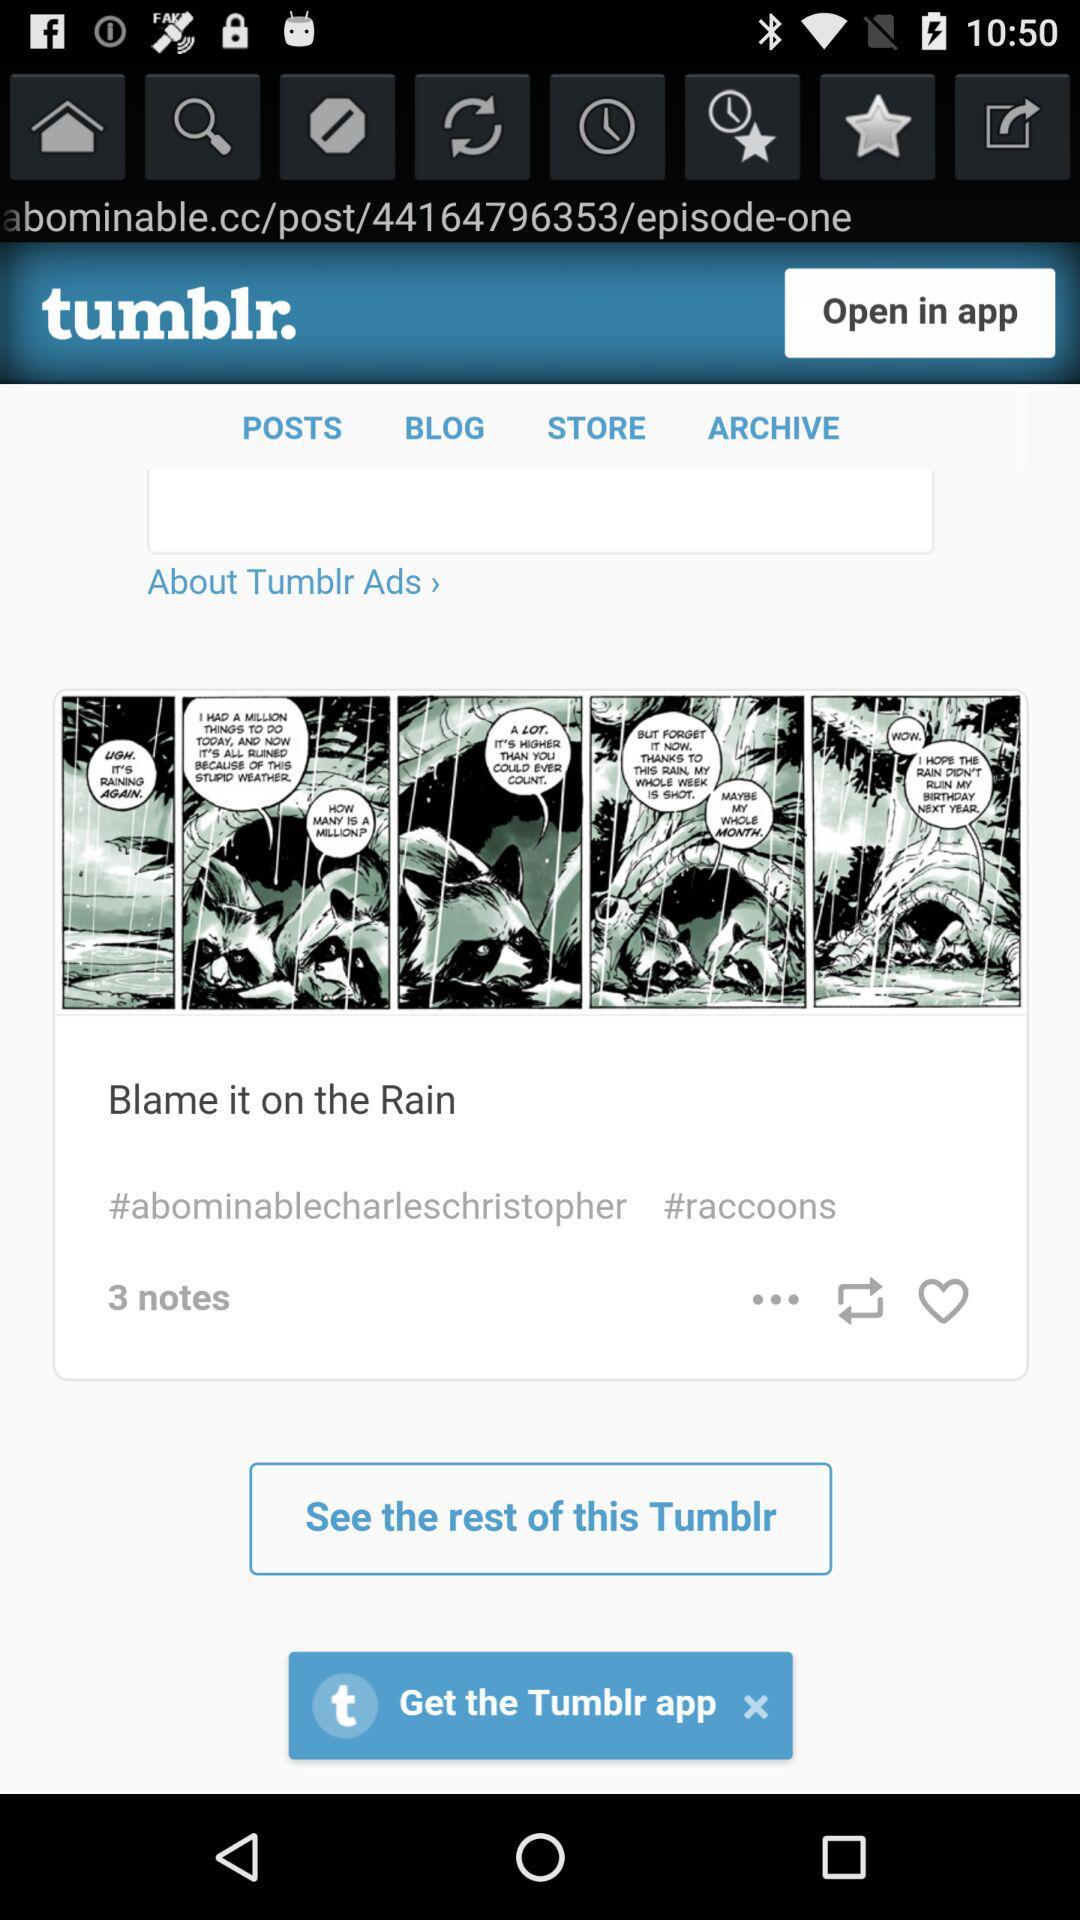What is the name of the application? The name of the application is "tumblr". 